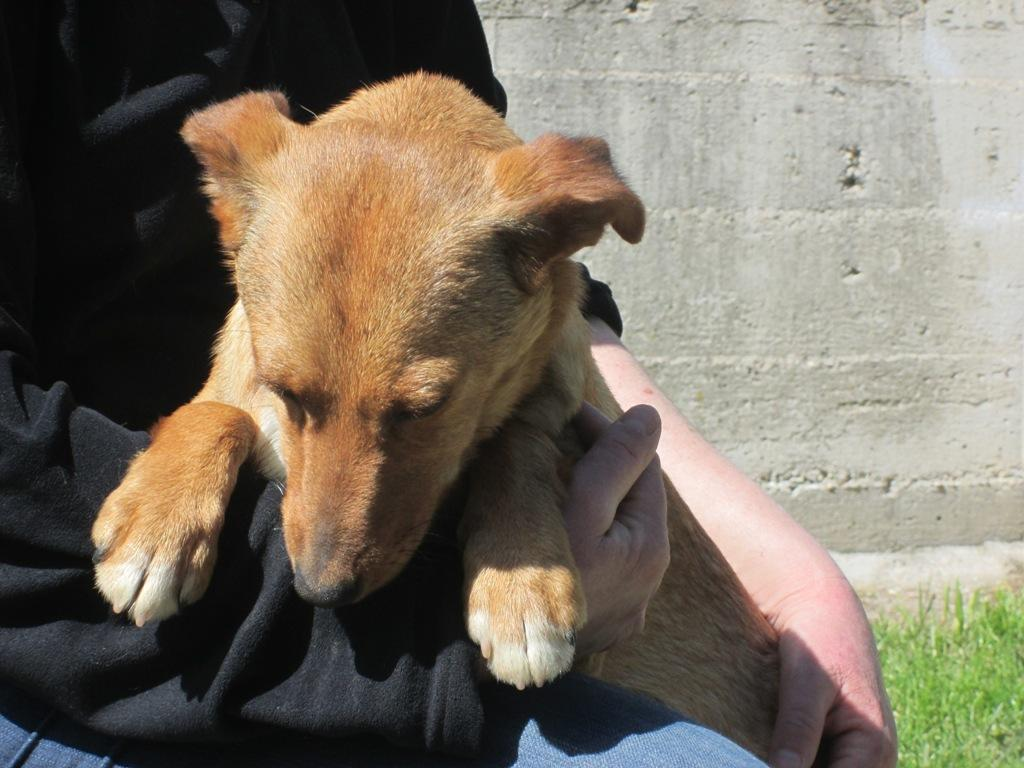Who or what is the main subject in the image? There is a person in the image. What is the person doing in the image? The person is holding a dog. What type of surface is visible beneath the person and dog? There is grass visible in the image. What can be seen in the distance behind the person and dog? There is a wall in the background of the image. How many cakes are being served at the funeral in the image? There is no funeral or cakes present in the image; it features a person holding a dog on a grassy area with a wall in the background. 